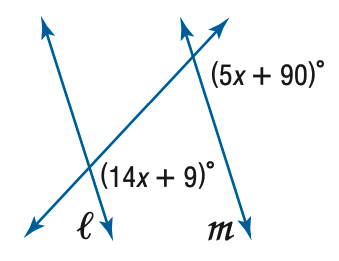Answer the mathemtical geometry problem and directly provide the correct option letter.
Question: Find x so that m \parallel n.
Choices: A: 9 B: 10 C: 11 D: 12 A 